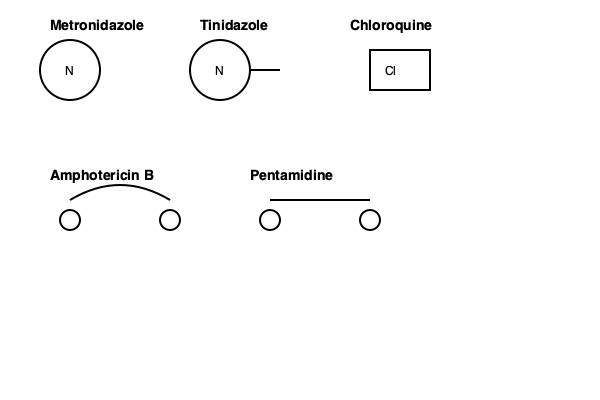Based on the structural representations shown, which antiprotozoal drug is most likely to have a broad spectrum of activity against both anaerobic protozoa and bacteria? To answer this question, we need to analyze the structural features of each drug and consider their implications for antimicrobial activity:

1. Metronidazole and Tinidazole:
   - Both contain a nitroimidazole ring (represented by the circle with "N").
   - Nitroimidazoles are known for their activity against anaerobic organisms.
   - The nitro group is reduced in anaerobic conditions, producing toxic metabolites.

2. Chloroquine:
   - Contains a quinoline ring (represented by the rectangle).
   - Primarily active against malaria parasites, not anaerobic organisms.

3. Amphotericin B:
   - Large, complex structure with a polyene component (curved line).
   - Primarily used as an antifungal agent, not for anaerobic protozoa or bacteria.

4. Pentamidine:
   - Linear structure with aromatic end groups.
   - Used mainly against specific protozoa like Pneumocystis jirovecii, not a broad-spectrum agent.

Among these, Metronidazole and Tinidazole have the most suitable structure for broad-spectrum activity against anaerobic protozoa and bacteria. Their nitroimidazole ring is key to their mechanism of action in anaerobic environments.

Metronidazole, being the simpler and more widely used of the two, is the most likely answer. It has been extensively studied and used clinically for a wide range of anaerobic infections, both protozoal and bacterial.
Answer: Metronidazole 